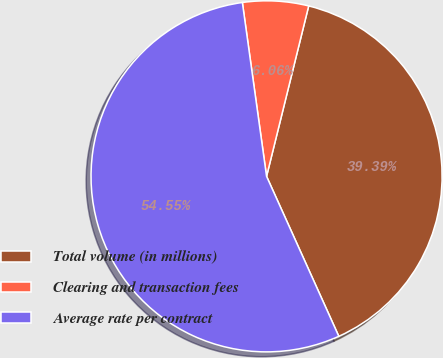<chart> <loc_0><loc_0><loc_500><loc_500><pie_chart><fcel>Total volume (in millions)<fcel>Clearing and transaction fees<fcel>Average rate per contract<nl><fcel>39.39%<fcel>6.06%<fcel>54.55%<nl></chart> 